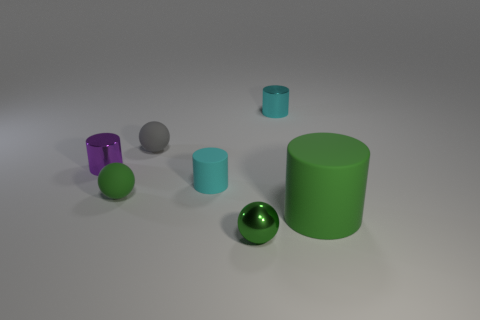Subtract all cyan cylinders. How many were subtracted if there are1cyan cylinders left? 1 Add 1 large matte cylinders. How many objects exist? 8 Subtract all cylinders. How many objects are left? 3 Add 4 tiny purple cylinders. How many tiny purple cylinders exist? 5 Subtract 0 purple spheres. How many objects are left? 7 Subtract all metallic cylinders. Subtract all small green metal spheres. How many objects are left? 4 Add 4 cyan rubber cylinders. How many cyan rubber cylinders are left? 5 